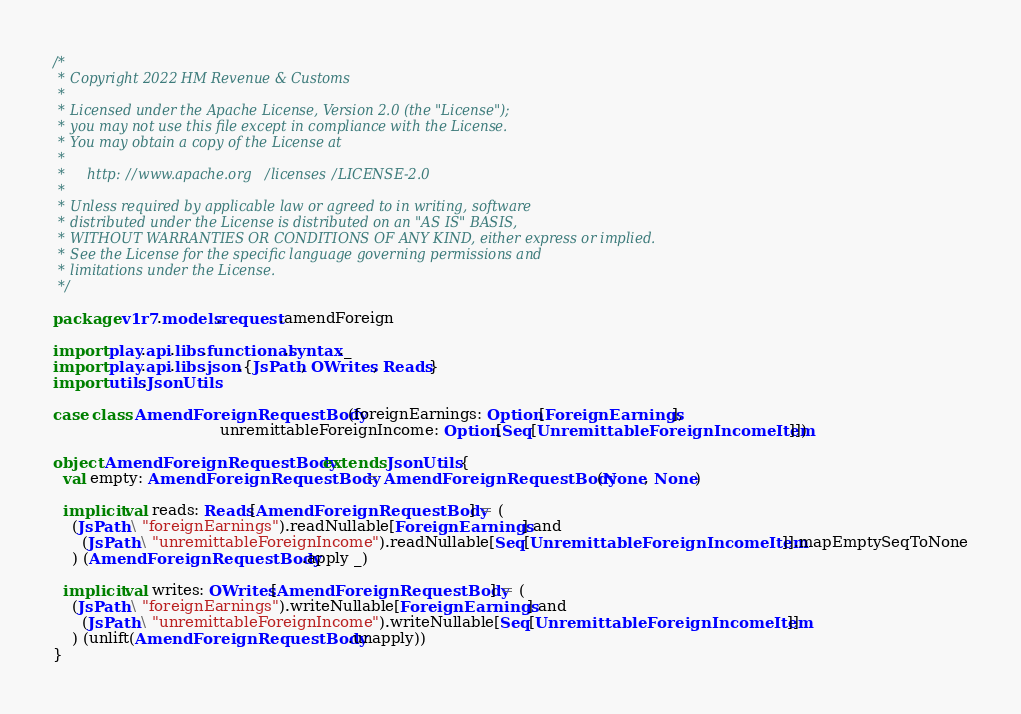Convert code to text. <code><loc_0><loc_0><loc_500><loc_500><_Scala_>/*
 * Copyright 2022 HM Revenue & Customs
 *
 * Licensed under the Apache License, Version 2.0 (the "License");
 * you may not use this file except in compliance with the License.
 * You may obtain a copy of the License at
 *
 *     http://www.apache.org/licenses/LICENSE-2.0
 *
 * Unless required by applicable law or agreed to in writing, software
 * distributed under the License is distributed on an "AS IS" BASIS,
 * WITHOUT WARRANTIES OR CONDITIONS OF ANY KIND, either express or implied.
 * See the License for the specific language governing permissions and
 * limitations under the License.
 */

package v1r7.models.request.amendForeign

import play.api.libs.functional.syntax._
import play.api.libs.json.{JsPath, OWrites, Reads}
import utils.JsonUtils

case class AmendForeignRequestBody(foreignEarnings: Option[ForeignEarnings],
                                   unremittableForeignIncome: Option[Seq[UnremittableForeignIncomeItem]])

object AmendForeignRequestBody extends JsonUtils {
  val empty: AmendForeignRequestBody = AmendForeignRequestBody(None, None)

  implicit val reads: Reads[AmendForeignRequestBody] = (
    (JsPath \ "foreignEarnings").readNullable[ForeignEarnings] and
      (JsPath \ "unremittableForeignIncome").readNullable[Seq[UnremittableForeignIncomeItem]].mapEmptySeqToNone
    ) (AmendForeignRequestBody.apply _)

  implicit val writes: OWrites[AmendForeignRequestBody] = (
    (JsPath \ "foreignEarnings").writeNullable[ForeignEarnings] and
      (JsPath \ "unremittableForeignIncome").writeNullable[Seq[UnremittableForeignIncomeItem]]
    ) (unlift(AmendForeignRequestBody.unapply))
}
</code> 